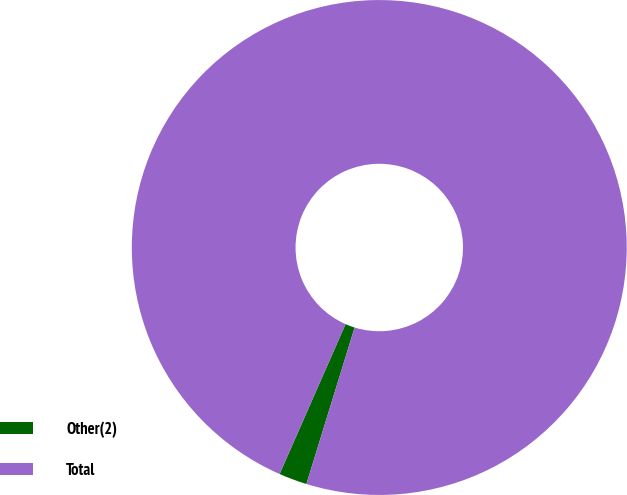Convert chart. <chart><loc_0><loc_0><loc_500><loc_500><pie_chart><fcel>Other(2)<fcel>Total<nl><fcel>1.84%<fcel>98.16%<nl></chart> 